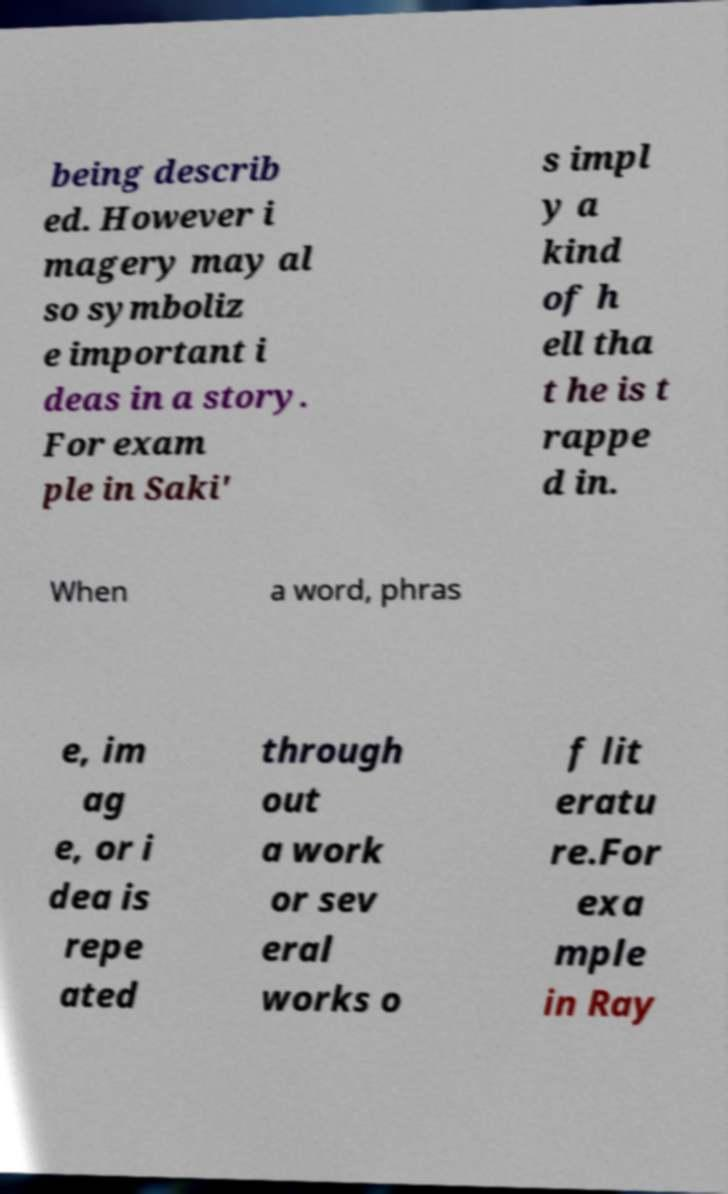There's text embedded in this image that I need extracted. Can you transcribe it verbatim? being describ ed. However i magery may al so symboliz e important i deas in a story. For exam ple in Saki' s impl y a kind of h ell tha t he is t rappe d in. When a word, phras e, im ag e, or i dea is repe ated through out a work or sev eral works o f lit eratu re.For exa mple in Ray 